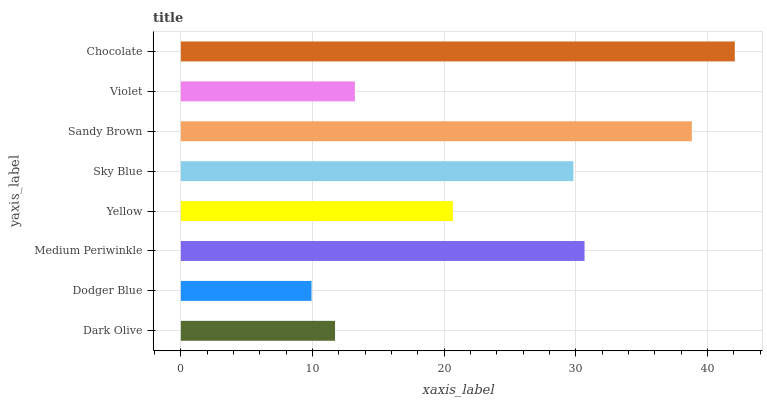Is Dodger Blue the minimum?
Answer yes or no. Yes. Is Chocolate the maximum?
Answer yes or no. Yes. Is Medium Periwinkle the minimum?
Answer yes or no. No. Is Medium Periwinkle the maximum?
Answer yes or no. No. Is Medium Periwinkle greater than Dodger Blue?
Answer yes or no. Yes. Is Dodger Blue less than Medium Periwinkle?
Answer yes or no. Yes. Is Dodger Blue greater than Medium Periwinkle?
Answer yes or no. No. Is Medium Periwinkle less than Dodger Blue?
Answer yes or no. No. Is Sky Blue the high median?
Answer yes or no. Yes. Is Yellow the low median?
Answer yes or no. Yes. Is Chocolate the high median?
Answer yes or no. No. Is Violet the low median?
Answer yes or no. No. 